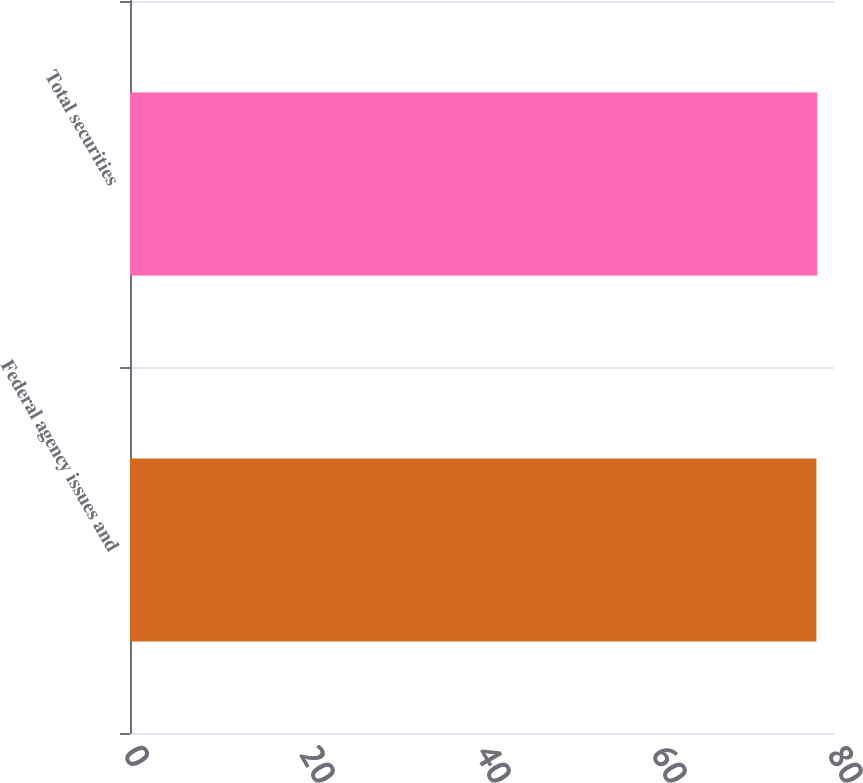<chart> <loc_0><loc_0><loc_500><loc_500><bar_chart><fcel>Federal agency issues and<fcel>Total securities<nl><fcel>78<fcel>78.1<nl></chart> 